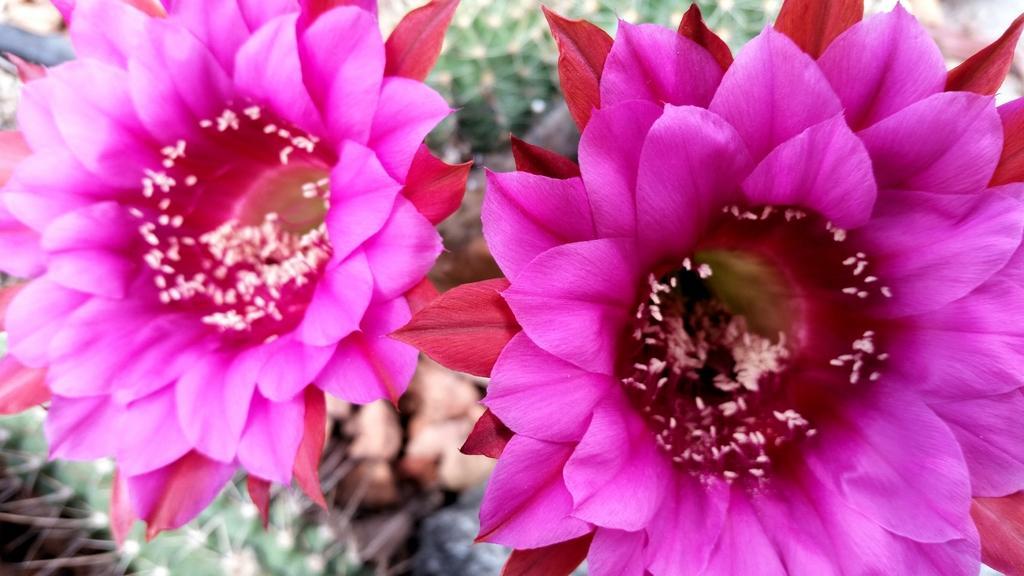In one or two sentences, can you explain what this image depicts? In this picture I can observe two pink color flowers. The background is blurred. 